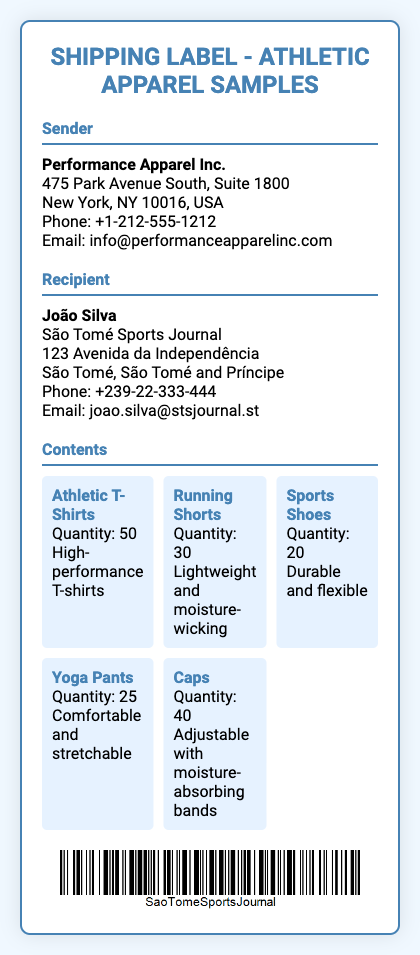What is the name of the sender? The sender's name is found at the top of the sender section in the document.
Answer: Performance Apparel Inc What is the recipient's email address? The email address of the recipient is included in the recipient section.
Answer: joao.silva@stsjournal.st How many athletic T-shirts are included in the shipment? The quantity of athletic T-shirts is specified under the contents section.
Answer: 50 What type of content is included with the cap? The specific detail about caps is provided in the content list.
Answer: Adjustable with moisture-absorbing bands What is the total number of running shorts? The total quantity can be found under the contents section next to running shorts.
Answer: 30 Which city is the sender located in? The city can be identified from the address listed under the sender's section.
Answer: New York How many items are shipped in total? The total quantity is the sum of all individual items listed in the contents section.
Answer: 165 What type of document is this? The nature of the document is indicated in the title at the top.
Answer: Shipping Label What phone number can be used to contact the sender? The contact number for the sender is displayed under the sender's details.
Answer: +1-212-555-1212 